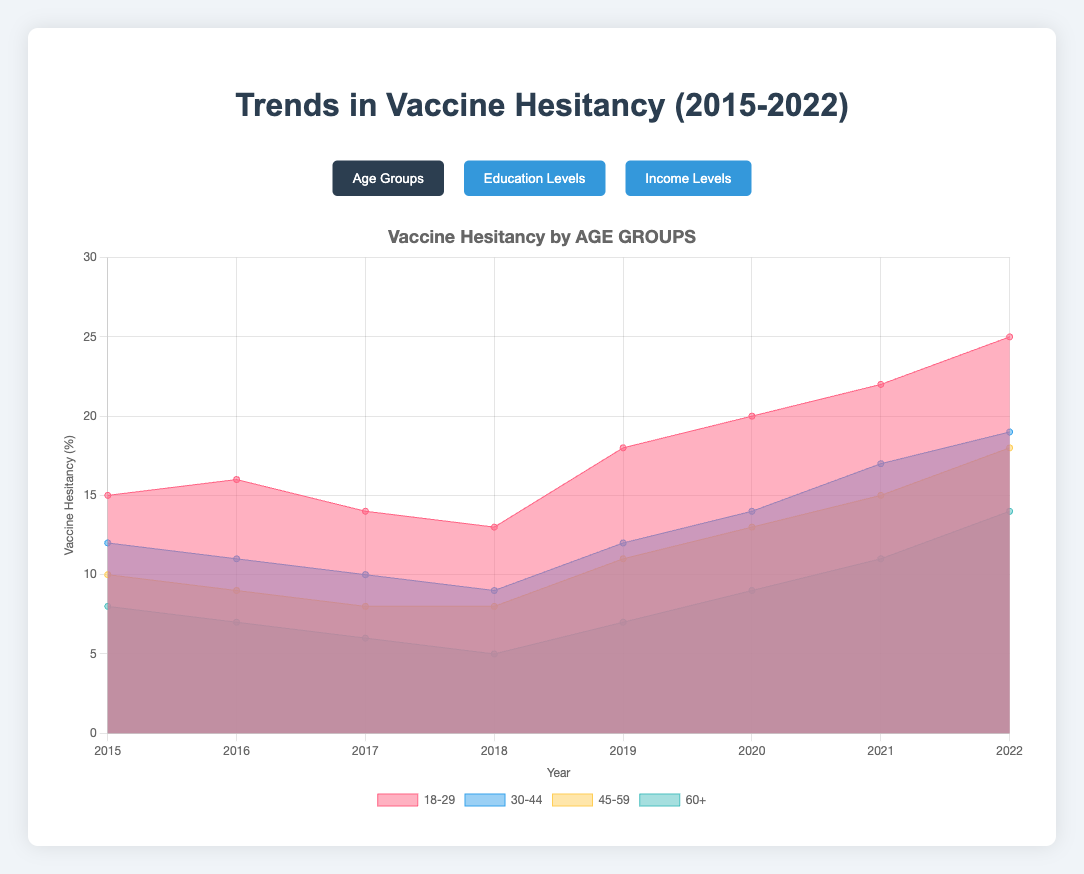What is the title of the chart? The title is located at the top of the chart, and it reads "Trends in Vaccine Hesitancy (2015-2022)."
Answer: Trends in Vaccine Hesitancy (2015-2022) Which age group has the highest vaccine hesitancy in 2022? Look at the age group data for the year 2022 and compare the values. The highest value for 2022 is in the "18-29" age group, which has a value of 25%.
Answer: 18-29 What is the rate of increase in vaccine hesitancy for the "30-44" age group from 2019 to 2022? Subtract the 2019 value from the 2022 value for the "30-44" age group: 19% (2022) - 12% (2019) = 7%. So, the rate of increase over three years is 7%.
Answer: 7% Compare the vaccine hesitancy trends between age groups "45-59" and "60+" from 2018 to 2022. Which group shows a greater increase? Calculate the differences for both age groups between 2018 and 2022. For "45-59": 18% (2022) - 8% (2018) = 10%. For "60+": 14% (2022) - 5% (2018) = 9%. The "45-59" age group shows a greater increase.
Answer: 45-59 What is the overall trend in vaccine hesitancy for people with a "Bachelor's Degree" from 2015 to 2022? Observe the values for the "Bachelor's Degree" category from 2015 to 2022. The values generally increase from 10% to 16%, indicating an upward trend in vaccine hesitancy.
Answer: Upward trend Which income level group has the lowest vaccine hesitancy in 2017? Look at the data for 2017 across all income level groups. The lowest value is 5% for the "$100k+" group.
Answer: $100k+ Between the education levels "High School or Less" and "Postgraduate Degree," which shows a larger difference in vaccine hesitancy from 2015 to 2022? Compare the values for 2015 and 2022 for both groups. "High School or Less": 27% (2022) - 20% (2015) = 7%. "Postgraduate Degree": 11% (2022) - 6% (2015) = 5%. The "High School or Less" group shows a larger difference.
Answer: High School or Less What is the average vaccine hesitancy for income level "$30k-$60k" from 2015 to 2022? Sum the values for the "$30k-$60k" group from each year (12 + 11 + 10 + 9 + 12 + 14 + 15 + 18 = 101) and divide by the number of years (8): 101/8 ≈ 12.625.
Answer: ~12.6 In which year did the "Some College" education level see the highest increase in vaccine hesitancy from the previous year? Calculate the yearly differences for the "Some College" group and identify the largest increase: 2016 - 2015 = -1, 2017 - 2016 = -1, 2018 - 2017 = -2, 2019 - 2018 = 3, 2020 - 2019 = 2, 2021 - 2020 = 2, 2022 - 2021 = 3. The highest increase occurred in 2019 and 2022 with an increase of 3.
Answer: 2019 and 2022 